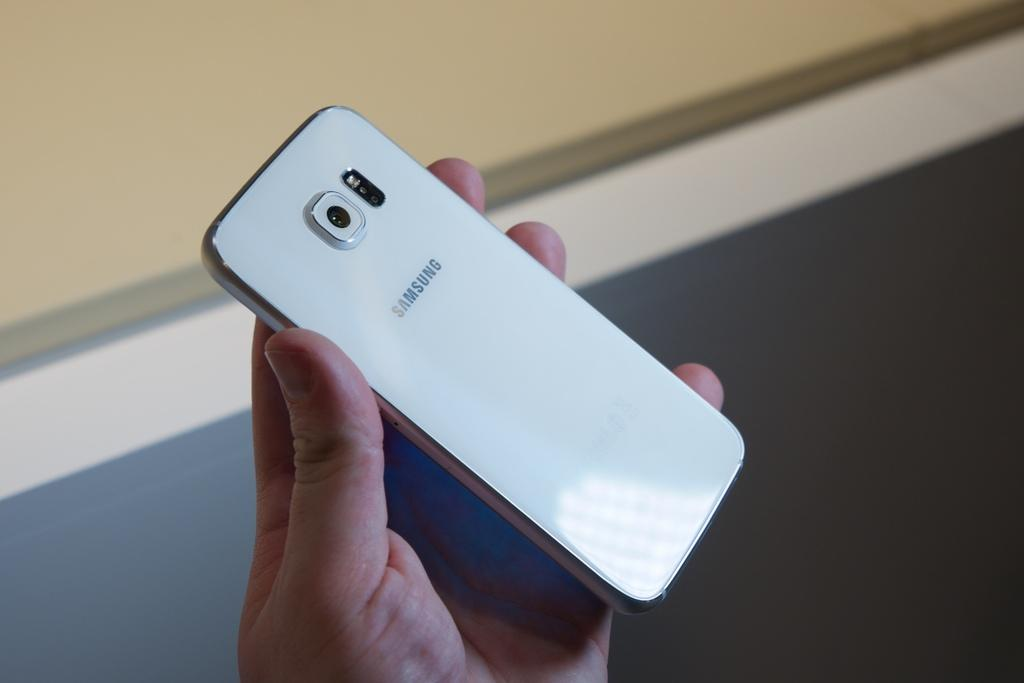<image>
Create a compact narrative representing the image presented. A person holding a white Samsung phone so that its back is facing up. 